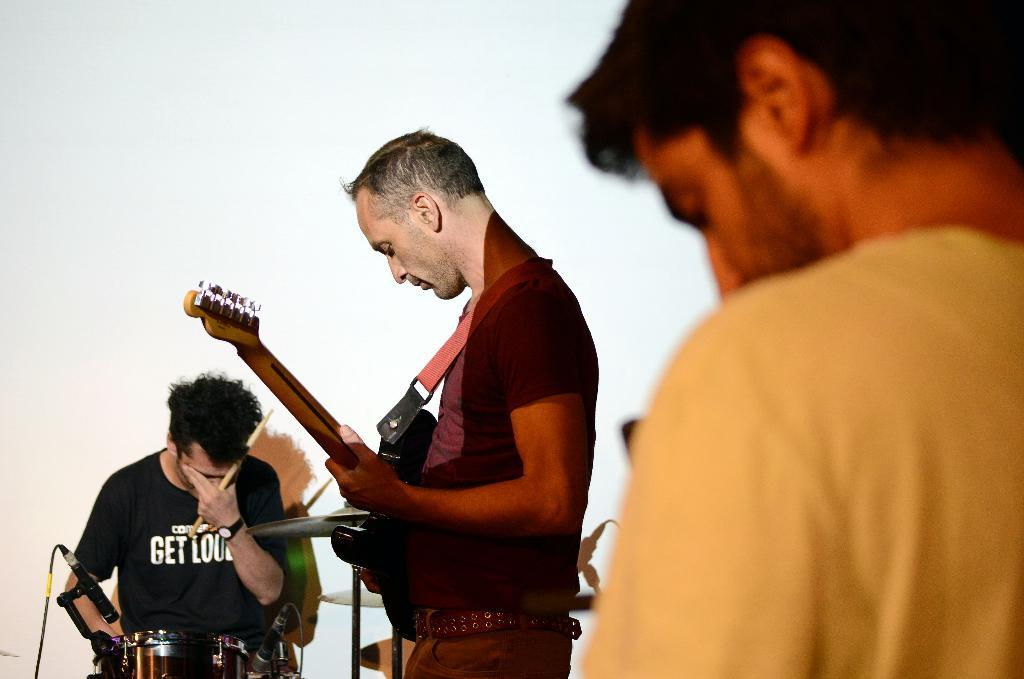How many people are in the image? There are three people in the image. What are the people doing in the image? The people are playing musical instruments. Can you describe any equipment related to their performance? Yes, there is a microphone in the image. What type of lunch is being served in the image? There is no lunch or food visible in the image. How does the image compare to a typical summer day? The image does not provide any information about the weather or season, so it cannot be compared to a typical summer day. 